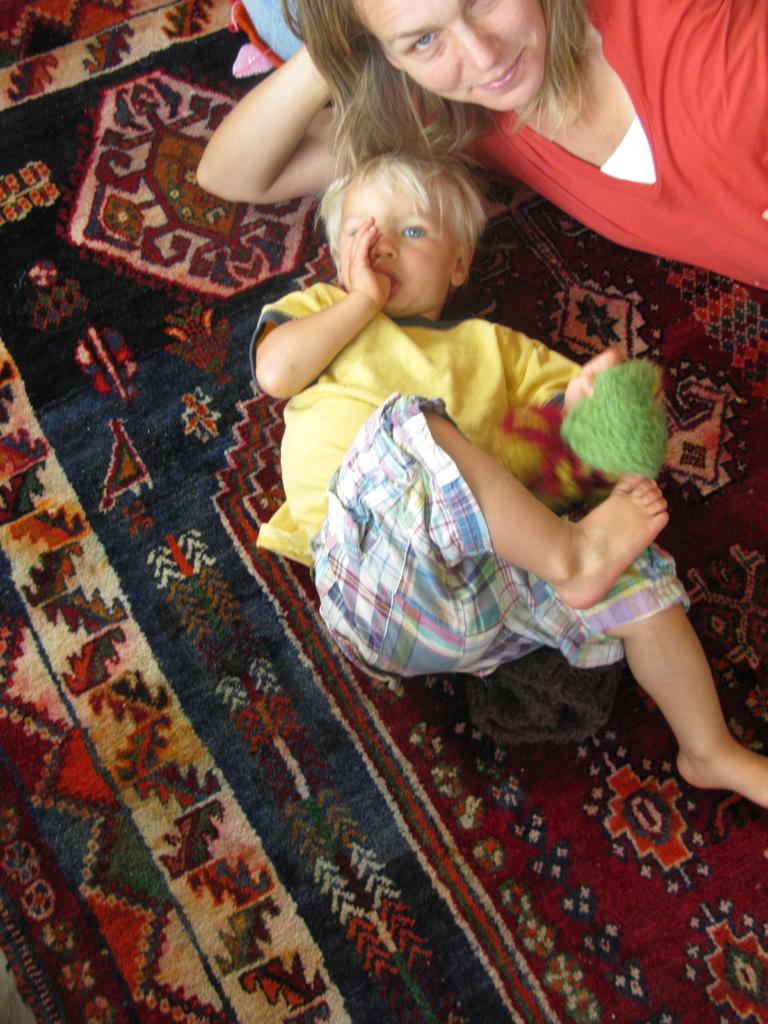Please provide a concise description of this image. In this image we can see a woman and a boy holding an object in his hand are laying on the surface. 